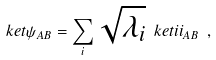Convert formula to latex. <formula><loc_0><loc_0><loc_500><loc_500>\ k e t { \psi } _ { A B } = \sum _ { i } \sqrt { \lambda _ { i } } \ k e t { i i } _ { A B } \ ,</formula> 